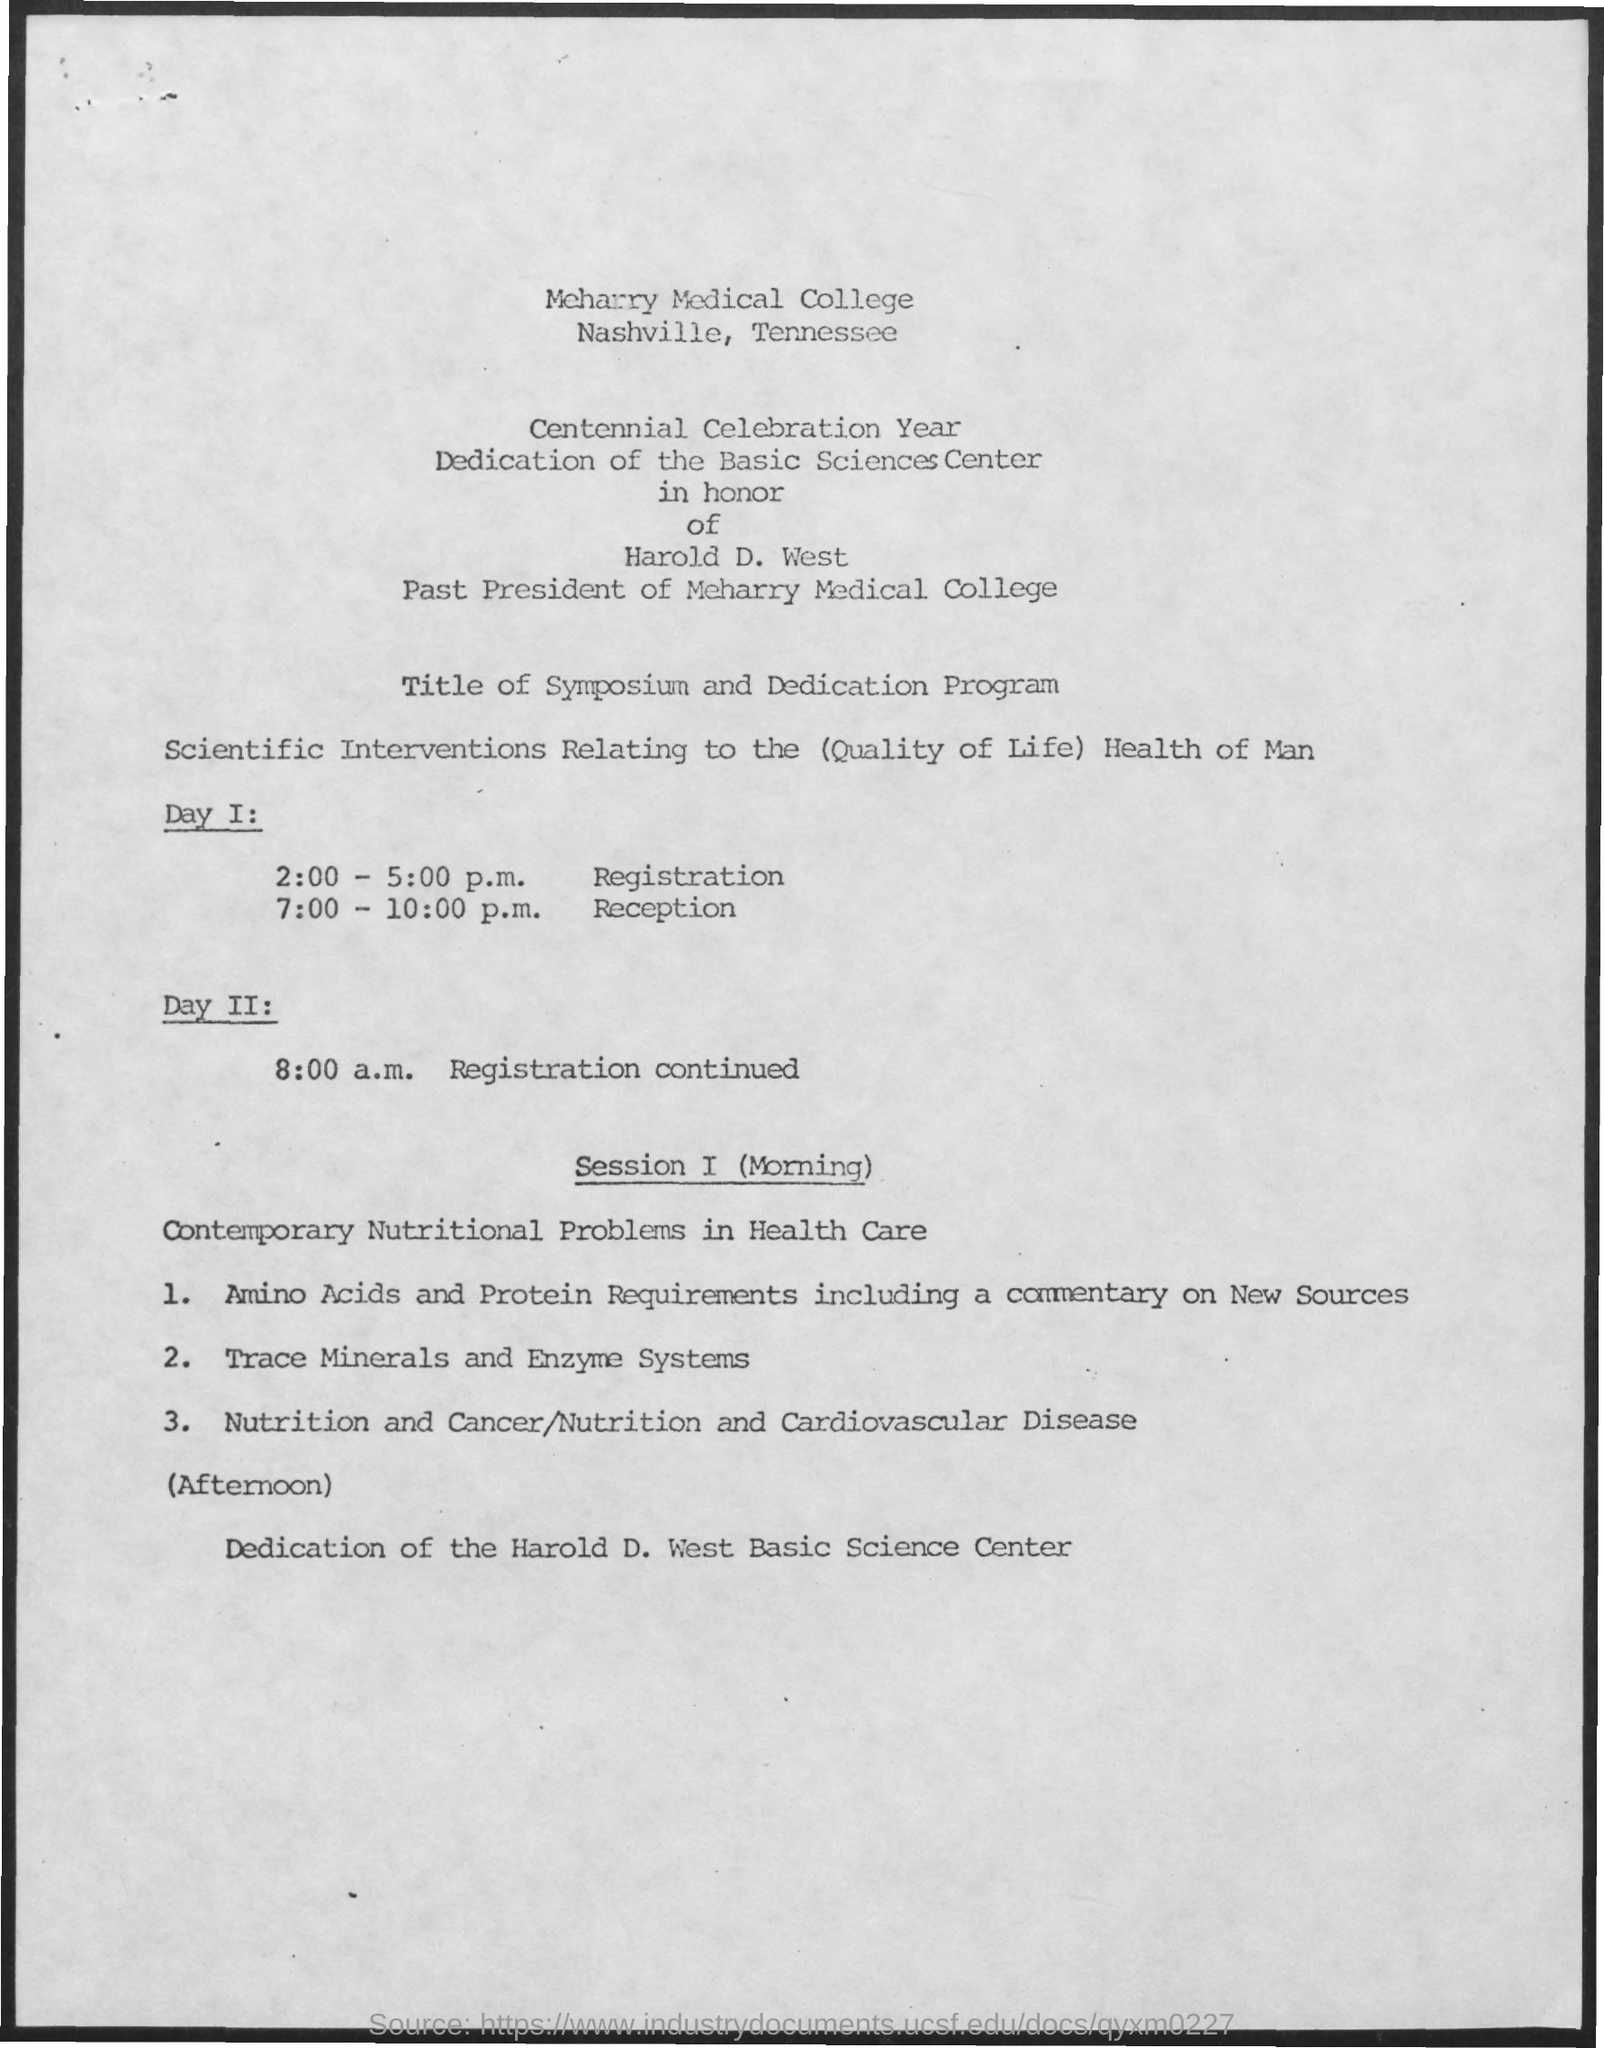Point out several critical features in this image. The schedule at 8:00 a.m. on day 2 will be as follows: registration, lunch, and opening remarks. At 7:00-10:00 p.m. on day 1, the schedule is as follows: Reception will take place. The schedule at 2:00-5:00 p.m. on day 1 is the registration process. 